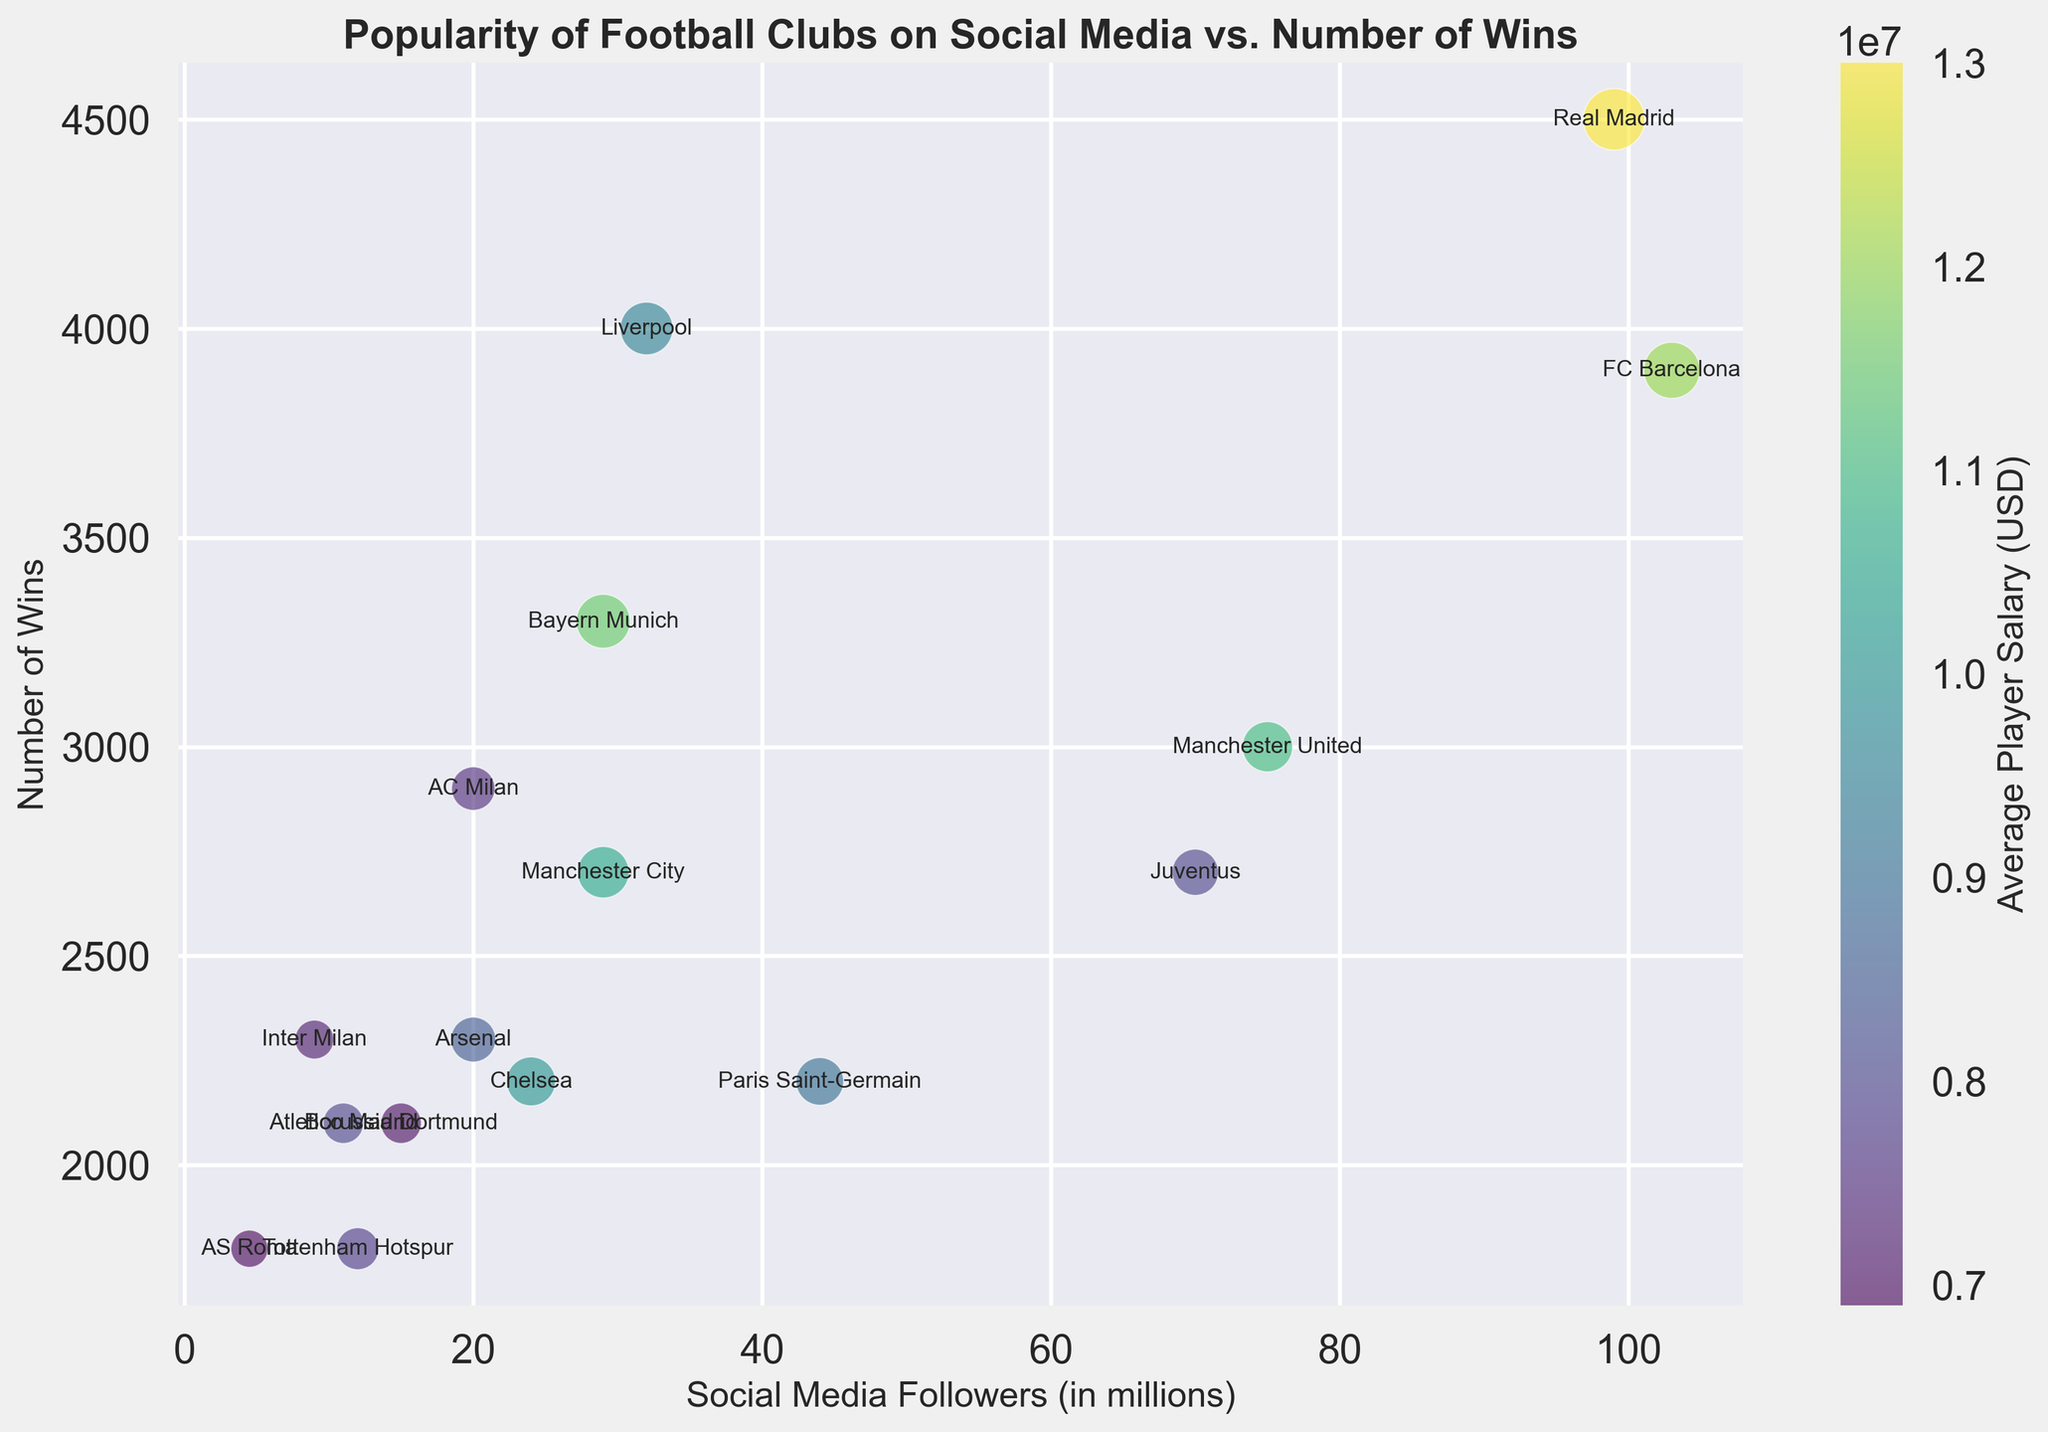How many clubs have more than 50 million social media followers? By examining the x-axis, which represents social media followers in millions, we see that FC Barcelona, Real Madrid, and Manchester United all have more than 50 million followers.
Answer: 3 Which club has the highest average player salary? The color bar indicates average player salary, and by looking for the club with the darkest color, Real Madrid can be identified as having the highest average player salary.
Answer: Real Madrid What is the difference in the number of wins between the club with the most wins and the club with the fewest wins? Real Madrid has the highest number of wins (4500) and Tottenham Hotspur has the fewest wins (1800). Therefore, the difference is calculated as 4500 - 1800.
Answer: 2700 Which clubs have a bubble size greater than 20? By examining the sizes of the bubbles, the clubs with bubble sizes greater than 20 are FC Barcelona, Real Madrid, Liverpool, and Bayern Munich as they have visibly larger bubbles compared to others.
Answer: 4 How many wins do FC Barcelona and Paris Saint-Germain have combined? FC Barcelona has 3900 wins and Paris Saint-Germain has 2200 wins. The combined total is 3900 + 2200.
Answer: 6100 Is there a correlation between the number of social media followers and the average player salary? Observing the trend in the data points, clubs with higher social media followers generally have higher average player salaries, indicating a positive correlation.
Answer: Yes Which club has the biggest bubble size and how many wins does it have? The largest bubble belongs to Real Madrid, and it has 4500 wins.
Answer: Real Madrid, 4500 Which club has fewer wins: Chelsea or AS Roma? By looking at the bubble positions on the y-axis, AS Roma (1800 wins) has fewer wins compared to Chelsea (2200 wins).
Answer: AS Roma Do more successful clubs (in terms of wins) tend to have higher average player salaries? Observing the top portion of the y-axis where the number of wins is high, these clubs (e.g., FC Barcelona, Real Madrid, Liverpool) have darker colors indicating higher average player salaries. This shows a tendency.
Answer: Yes What is the social media follower range for Juventus and Bayern Munich combined? Juventus has 70 million followers and Bayern Munich has 29 million followers. Combined, their followers range from 29 million to 70 million.
Answer: 29 million to 70 million 